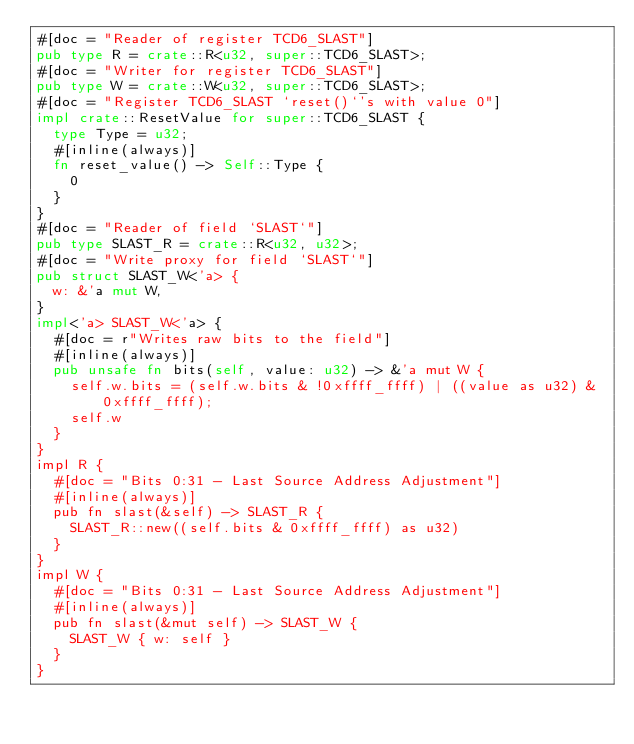Convert code to text. <code><loc_0><loc_0><loc_500><loc_500><_Rust_>#[doc = "Reader of register TCD6_SLAST"]
pub type R = crate::R<u32, super::TCD6_SLAST>;
#[doc = "Writer for register TCD6_SLAST"]
pub type W = crate::W<u32, super::TCD6_SLAST>;
#[doc = "Register TCD6_SLAST `reset()`'s with value 0"]
impl crate::ResetValue for super::TCD6_SLAST {
  type Type = u32;
  #[inline(always)]
  fn reset_value() -> Self::Type {
    0
  }
}
#[doc = "Reader of field `SLAST`"]
pub type SLAST_R = crate::R<u32, u32>;
#[doc = "Write proxy for field `SLAST`"]
pub struct SLAST_W<'a> {
  w: &'a mut W,
}
impl<'a> SLAST_W<'a> {
  #[doc = r"Writes raw bits to the field"]
  #[inline(always)]
  pub unsafe fn bits(self, value: u32) -> &'a mut W {
    self.w.bits = (self.w.bits & !0xffff_ffff) | ((value as u32) & 0xffff_ffff);
    self.w
  }
}
impl R {
  #[doc = "Bits 0:31 - Last Source Address Adjustment"]
  #[inline(always)]
  pub fn slast(&self) -> SLAST_R {
    SLAST_R::new((self.bits & 0xffff_ffff) as u32)
  }
}
impl W {
  #[doc = "Bits 0:31 - Last Source Address Adjustment"]
  #[inline(always)]
  pub fn slast(&mut self) -> SLAST_W {
    SLAST_W { w: self }
  }
}
</code> 